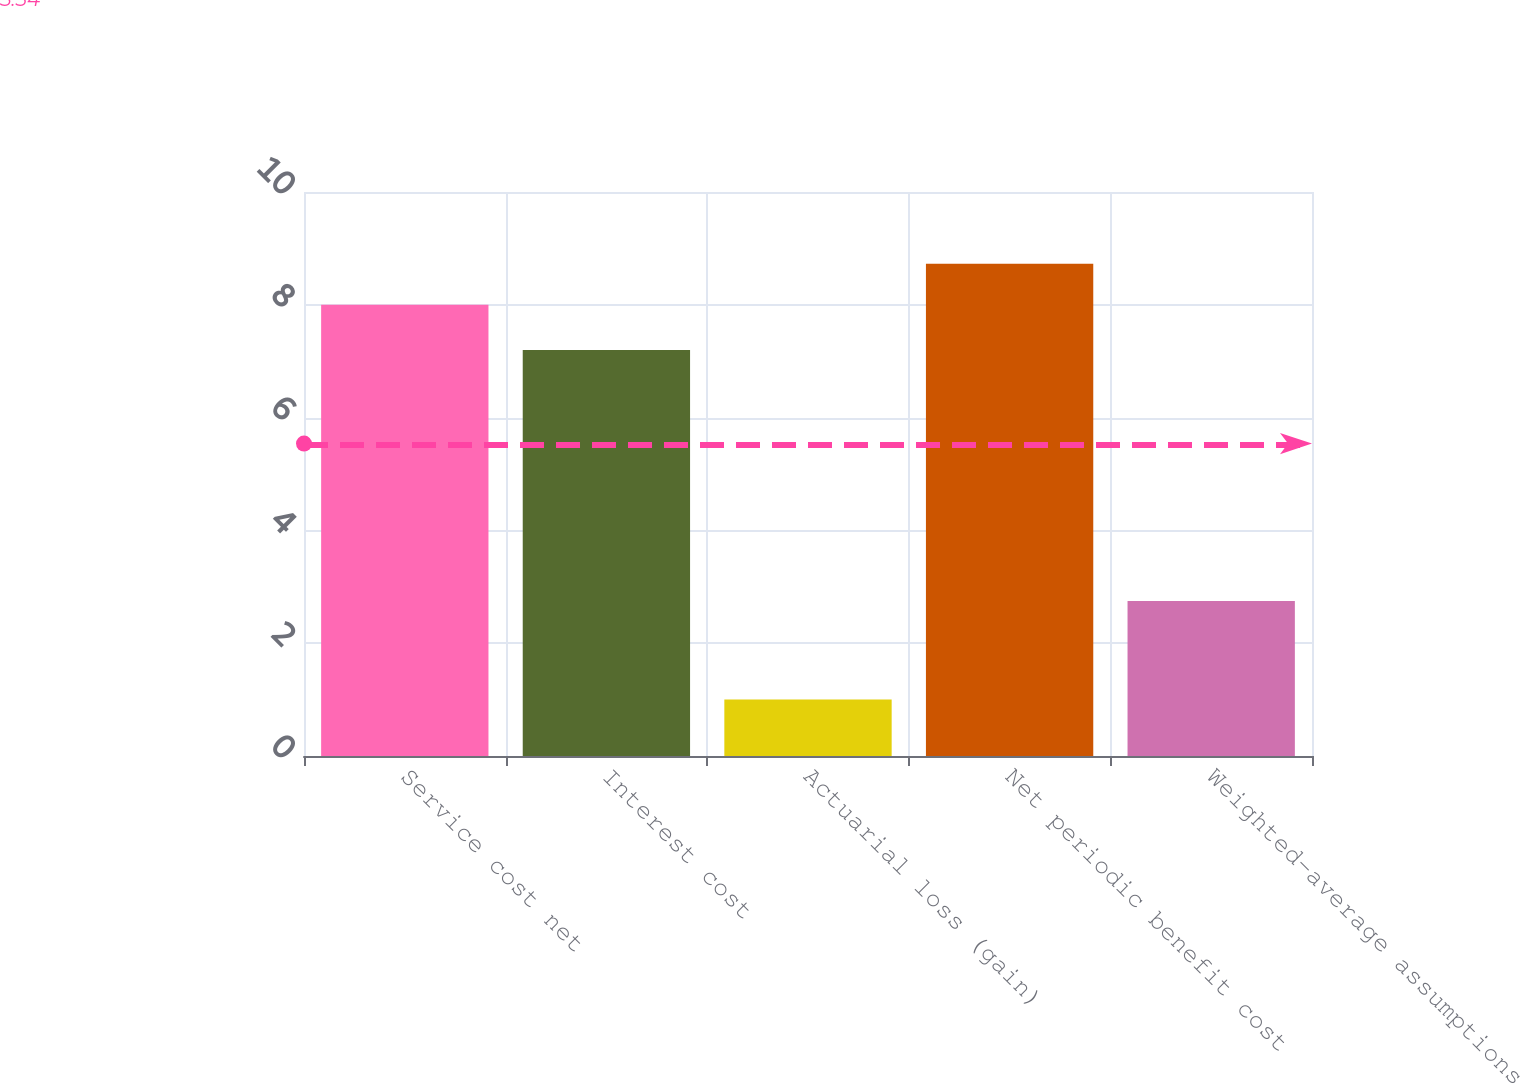Convert chart. <chart><loc_0><loc_0><loc_500><loc_500><bar_chart><fcel>Service cost net<fcel>Interest cost<fcel>Actuarial loss (gain)<fcel>Net periodic benefit cost<fcel>Weighted-average assumptions<nl><fcel>8<fcel>7.2<fcel>1<fcel>8.73<fcel>2.75<nl></chart> 